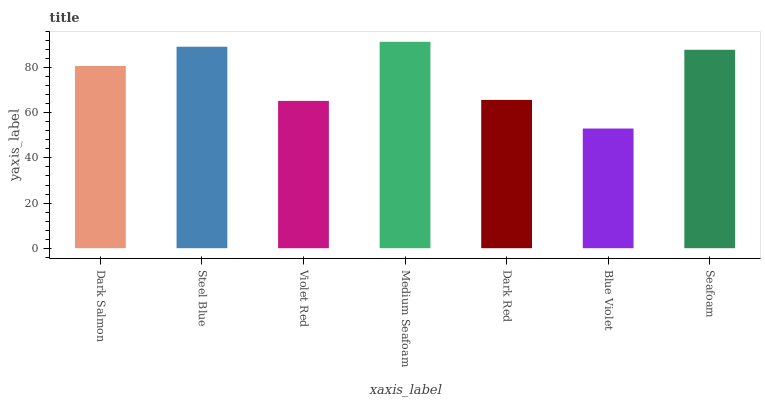Is Blue Violet the minimum?
Answer yes or no. Yes. Is Medium Seafoam the maximum?
Answer yes or no. Yes. Is Steel Blue the minimum?
Answer yes or no. No. Is Steel Blue the maximum?
Answer yes or no. No. Is Steel Blue greater than Dark Salmon?
Answer yes or no. Yes. Is Dark Salmon less than Steel Blue?
Answer yes or no. Yes. Is Dark Salmon greater than Steel Blue?
Answer yes or no. No. Is Steel Blue less than Dark Salmon?
Answer yes or no. No. Is Dark Salmon the high median?
Answer yes or no. Yes. Is Dark Salmon the low median?
Answer yes or no. Yes. Is Seafoam the high median?
Answer yes or no. No. Is Dark Red the low median?
Answer yes or no. No. 